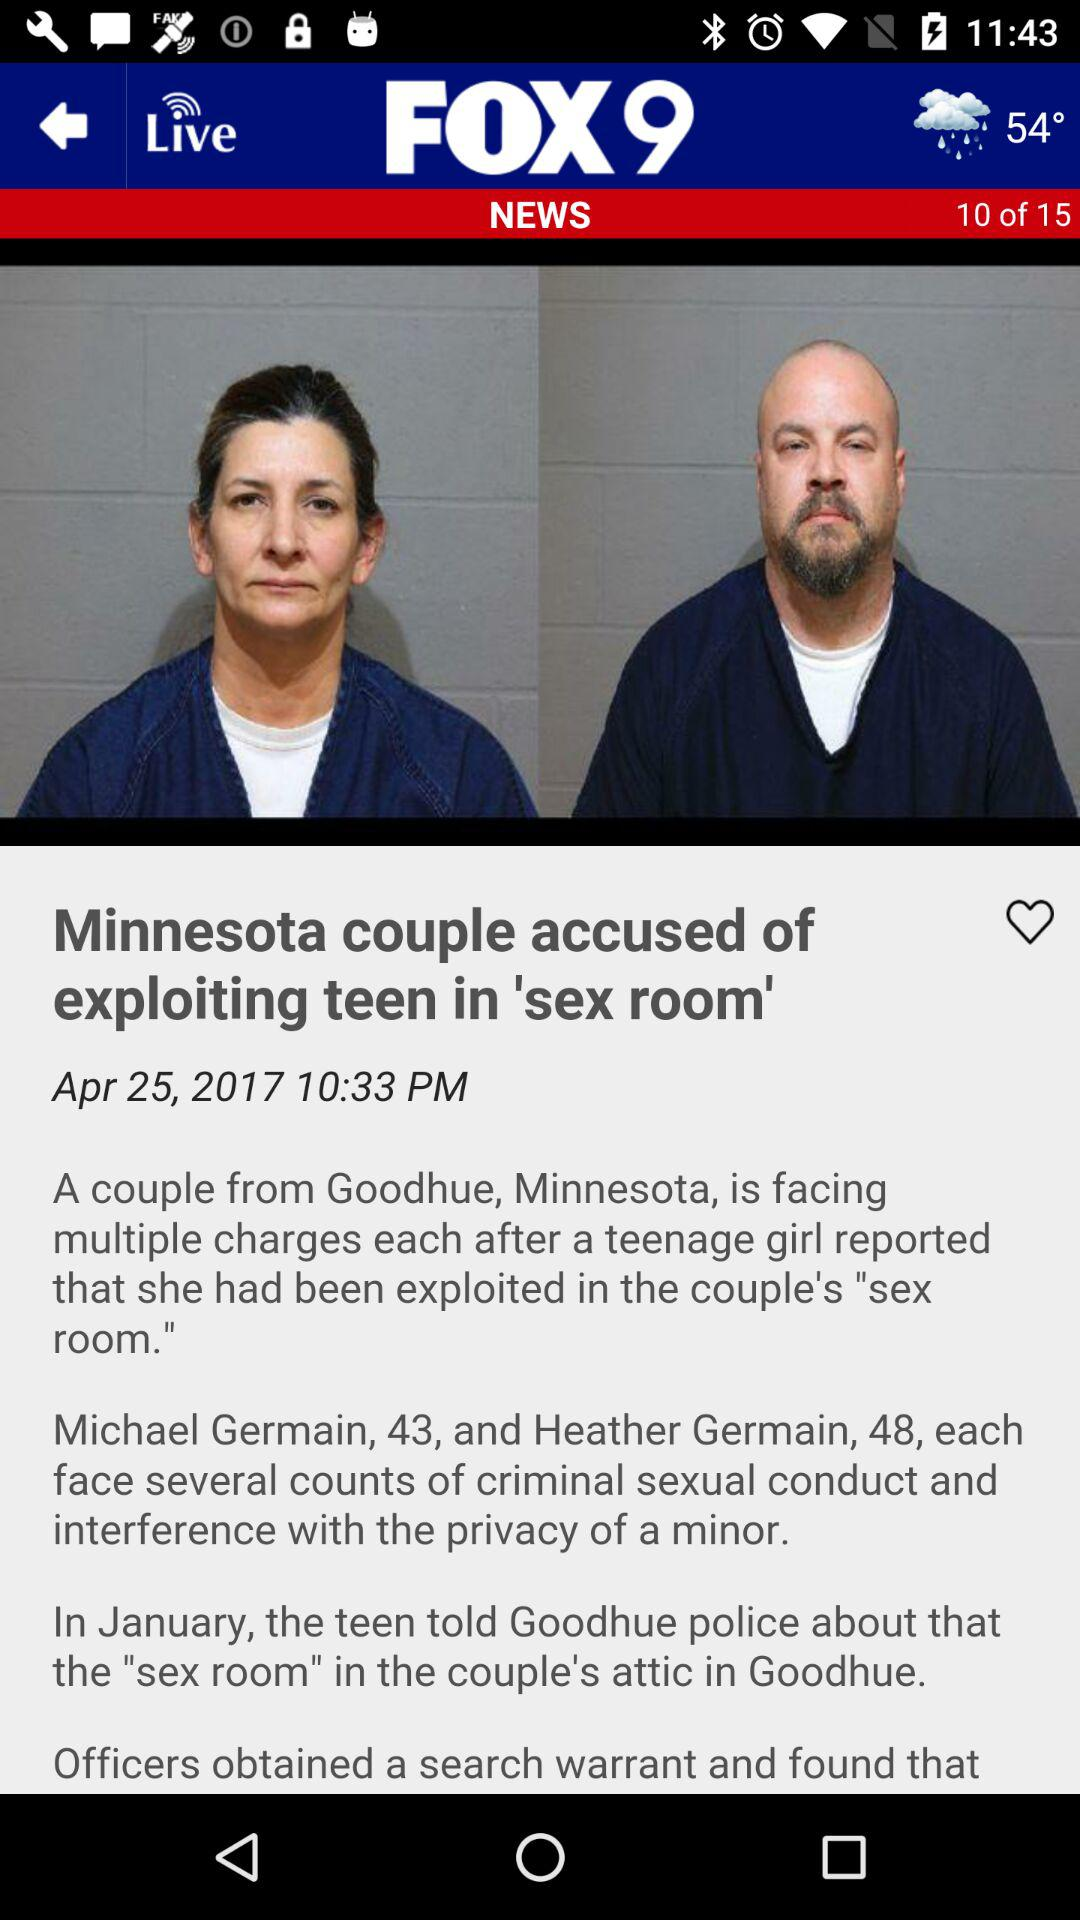How many slides in total are shown? A total of 15 slides are shown. 